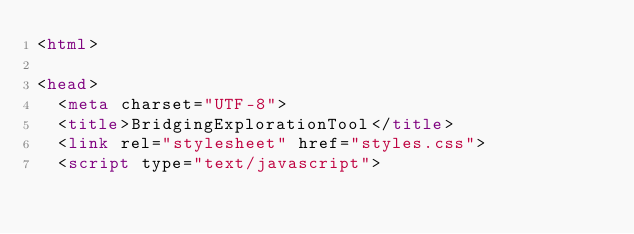Convert code to text. <code><loc_0><loc_0><loc_500><loc_500><_HTML_><html>

<head>
	<meta charset="UTF-8">
	<title>BridgingExplorationTool</title>
	<link rel="stylesheet" href="styles.css">
	<script type="text/javascript"></code> 